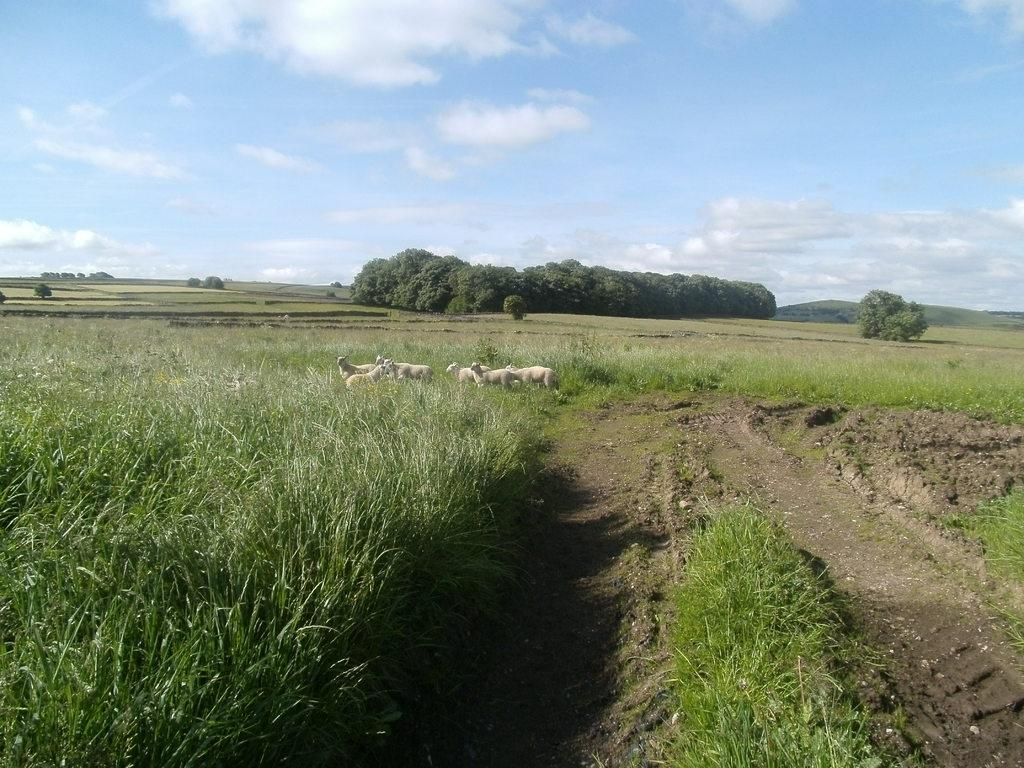What type of animals can be seen in the image? There are herds of animals in the image. Where are the animals located? The animals are in a farm. What type of vegetation is present in the image? There is grass in the image, and plants and trees can be seen in the background. What can be seen in the distance in the image? There are mountains and the sky visible in the background of the image. When do you think the image was taken? The image was likely taken during the day, as the sky is visible. What type of force is being applied to the stone in the image? There is no stone present in the image, so it is not possible to determine if any force is being applied to it. 